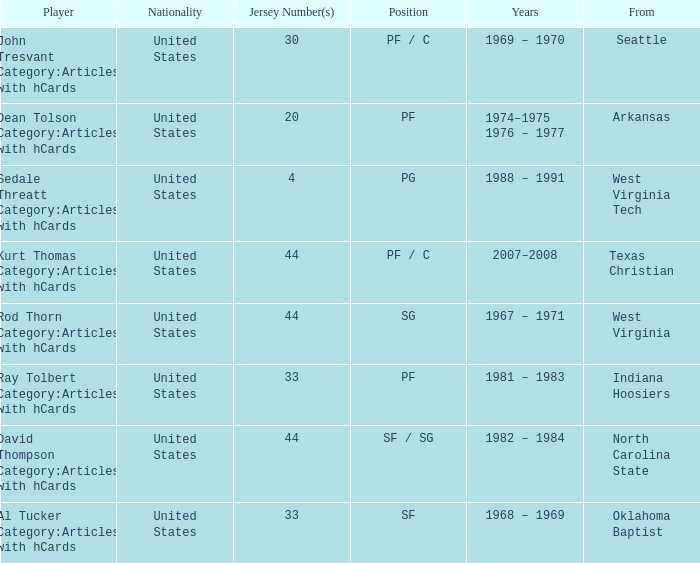What years did the player with the jersey number bigger than 20 play? 2007–2008, 1982 – 1984, 1967 – 1971, 1981 – 1983, 1969 – 1970, 1968 – 1969. Could you help me parse every detail presented in this table? {'header': ['Player', 'Nationality', 'Jersey Number(s)', 'Position', 'Years', 'From'], 'rows': [['John Tresvant Category:Articles with hCards', 'United States', '30', 'PF / C', '1969 – 1970', 'Seattle'], ['Dean Tolson Category:Articles with hCards', 'United States', '20', 'PF', '1974–1975 1976 – 1977', 'Arkansas'], ['Sedale Threatt Category:Articles with hCards', 'United States', '4', 'PG', '1988 – 1991', 'West Virginia Tech'], ['Kurt Thomas Category:Articles with hCards', 'United States', '44', 'PF / C', '2007–2008', 'Texas Christian'], ['Rod Thorn Category:Articles with hCards', 'United States', '44', 'SG', '1967 – 1971', 'West Virginia'], ['Ray Tolbert Category:Articles with hCards', 'United States', '33', 'PF', '1981 – 1983', 'Indiana Hoosiers'], ['David Thompson Category:Articles with hCards', 'United States', '44', 'SF / SG', '1982 – 1984', 'North Carolina State'], ['Al Tucker Category:Articles with hCards', 'United States', '33', 'SF', '1968 – 1969', 'Oklahoma Baptist']]} 